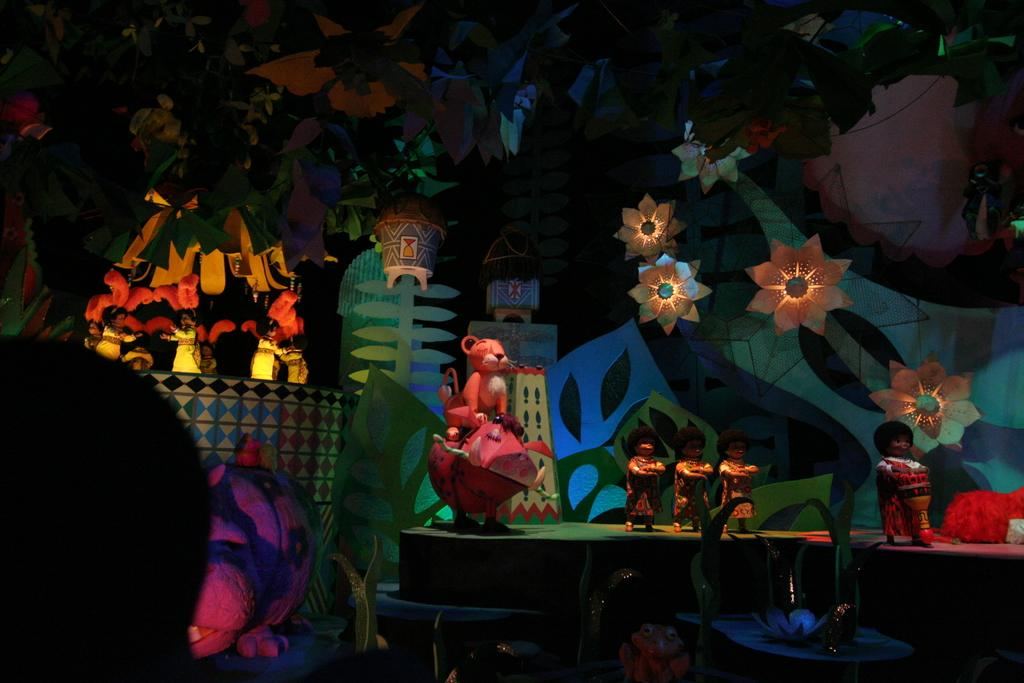What objects can be seen in the image? There are lights and toys in the image. What can be observed about the background of the image? The background of the image is dark. How many chickens are visible in the image? There are no chickens present in the image. What type of cactus can be seen in the image? There is no cactus present in the image. 